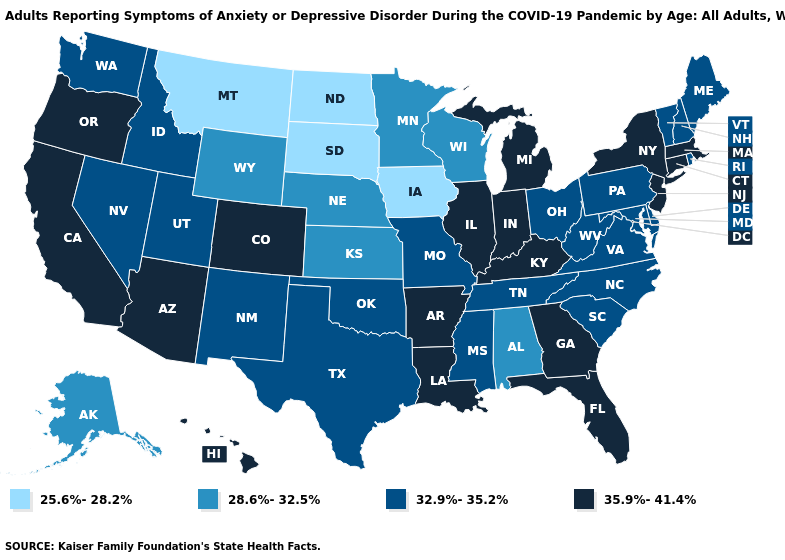Does Pennsylvania have the highest value in the Northeast?
Give a very brief answer. No. Name the states that have a value in the range 28.6%-32.5%?
Be succinct. Alabama, Alaska, Kansas, Minnesota, Nebraska, Wisconsin, Wyoming. Which states have the lowest value in the South?
Short answer required. Alabama. What is the lowest value in the USA?
Write a very short answer. 25.6%-28.2%. Does the map have missing data?
Give a very brief answer. No. Name the states that have a value in the range 35.9%-41.4%?
Be succinct. Arizona, Arkansas, California, Colorado, Connecticut, Florida, Georgia, Hawaii, Illinois, Indiana, Kentucky, Louisiana, Massachusetts, Michigan, New Jersey, New York, Oregon. Among the states that border Texas , does New Mexico have the highest value?
Be succinct. No. What is the value of Alabama?
Write a very short answer. 28.6%-32.5%. Among the states that border Michigan , which have the lowest value?
Quick response, please. Wisconsin. Among the states that border Florida , does Alabama have the highest value?
Give a very brief answer. No. Which states hav the highest value in the Northeast?
Write a very short answer. Connecticut, Massachusetts, New Jersey, New York. What is the highest value in the Northeast ?
Concise answer only. 35.9%-41.4%. What is the value of Arkansas?
Be succinct. 35.9%-41.4%. What is the value of New York?
Answer briefly. 35.9%-41.4%. Does Illinois have the highest value in the MidWest?
Keep it brief. Yes. 